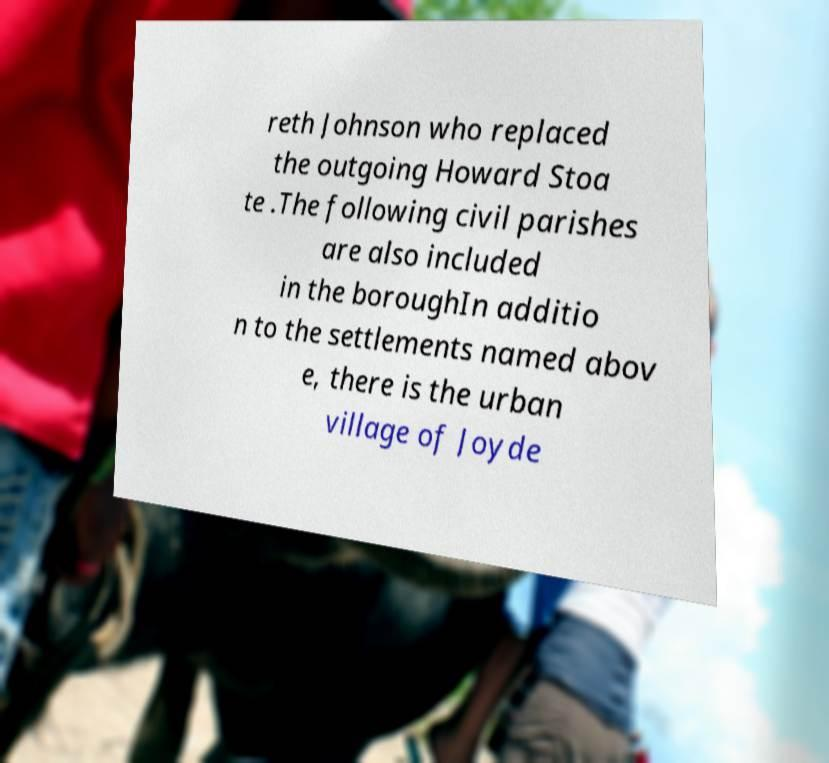What messages or text are displayed in this image? I need them in a readable, typed format. reth Johnson who replaced the outgoing Howard Stoa te .The following civil parishes are also included in the boroughIn additio n to the settlements named abov e, there is the urban village of Joyde 